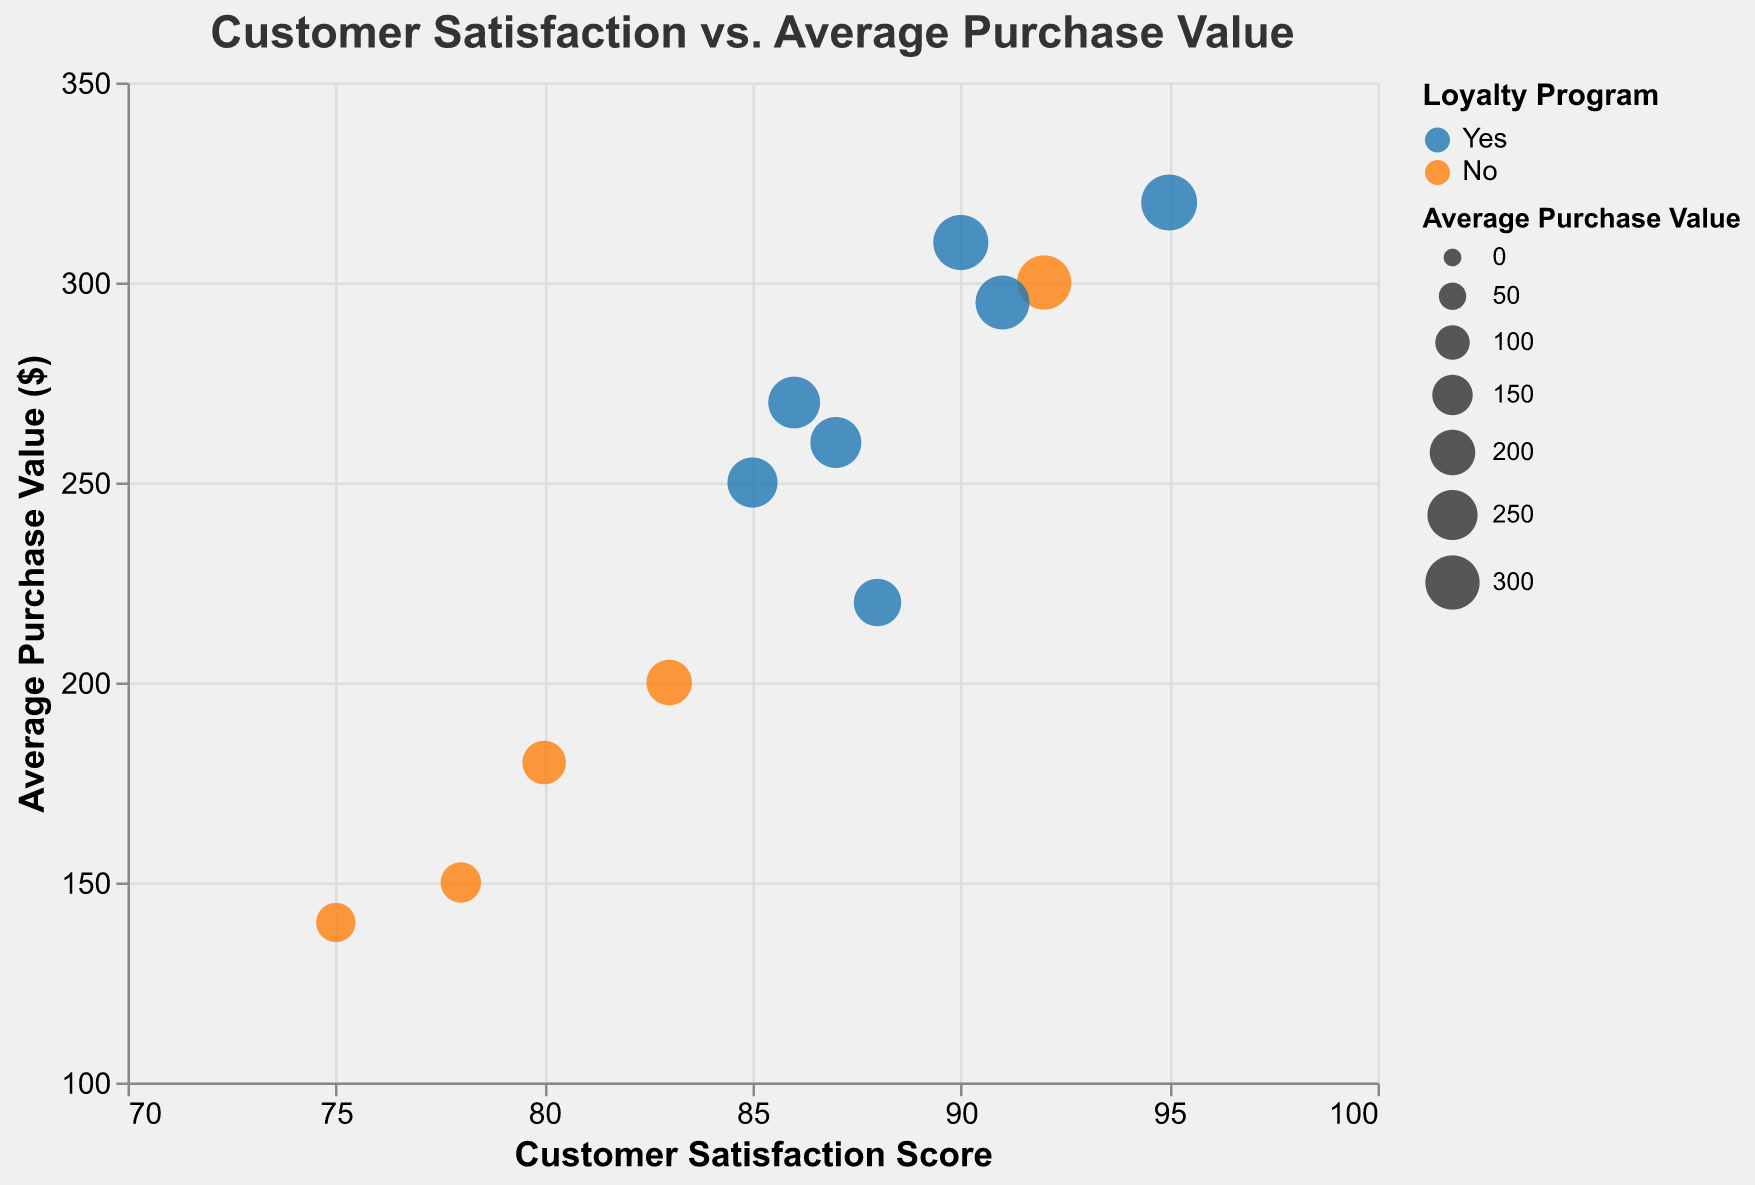What is the title of the chart? The title is typically located at the top of the chart and provides a brief description of the chart's focus.
Answer: Customer Satisfaction vs. Average Purchase Value How many customers are represented in the chart? Each bubble in the chart represents a customer. By counting the bubbles, we can determine the number of customers.
Answer: 12 Which axis represents the Customer Satisfaction Score? The vertical (y) and horizontal (x) axes represent different variables. The title of the axes indicates the variable they represent.
Answer: The horizontal (x) axis What color represents customers who are part of the Loyalty Program? The legend that explains the colors used will show which color corresponds to the Loyalty Program membership.
Answer: Blue Which customer has the highest average purchase value, and what is that value? Look for the bubble positioned highest along the y-axis and read the y-axis value.
Answer: Emily Davis, $320 Compare the Customer Satisfaction Score and Average Purchase Value of Jane Smith and Jessica Kim. Who has a higher satisfaction score, and who has a higher purchase value? Identify both customers' bubbles and compare their positions along the x-axis for satisfaction scores and the y-axis for purchase values.
Answer: Jessica Kim has a higher satisfaction score, but Jane Smith has a higher purchase value Is there a correlation between being in the Loyalty Program and having a high average purchase value? Observe if the blue bubbles (Loyalty Program members) are generally positioned higher on the y-axis compared to the orange bubbles.
Answer: Yes, Loyalty Program members tend to have a higher average purchase value Which tier within the Loyalty Program has the highest customer satisfaction score? Filter for the blue bubbles (Loyalty Program members) and compare their positions on the x-axis based on their tier labels.
Answer: Gold How does Michael Brown's average purchase value compare to the average purchase value of all customers? Find Michael Brown's average purchase value on the chart and calculate the average purchase value of all 12 customers, then compare.
Answer: Michael Brown's value is $180; the overall average is $239.17 What is the general trend you observe between Customer Satisfaction Score and Average Purchase Value? By observing the overall distribution of the bubbles, we can infer the general relationship between the two variables.
Answer: Higher satisfaction scores generally correlate with higher average purchase values 